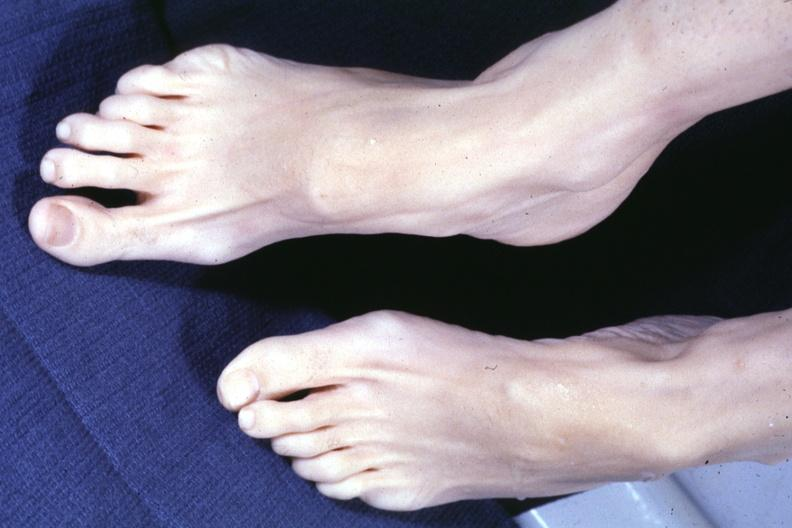re x-ray intramyocardial arteries present?
Answer the question using a single word or phrase. No 